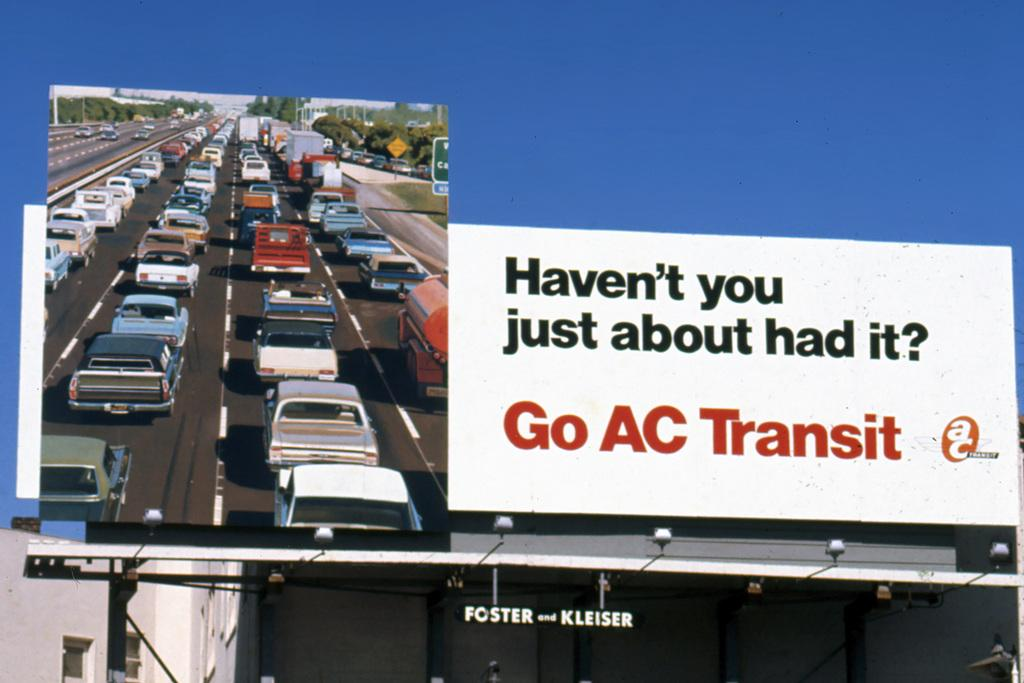<image>
Render a clear and concise summary of the photo. A large white sign shows traffic and says Haven't you just about had it. 